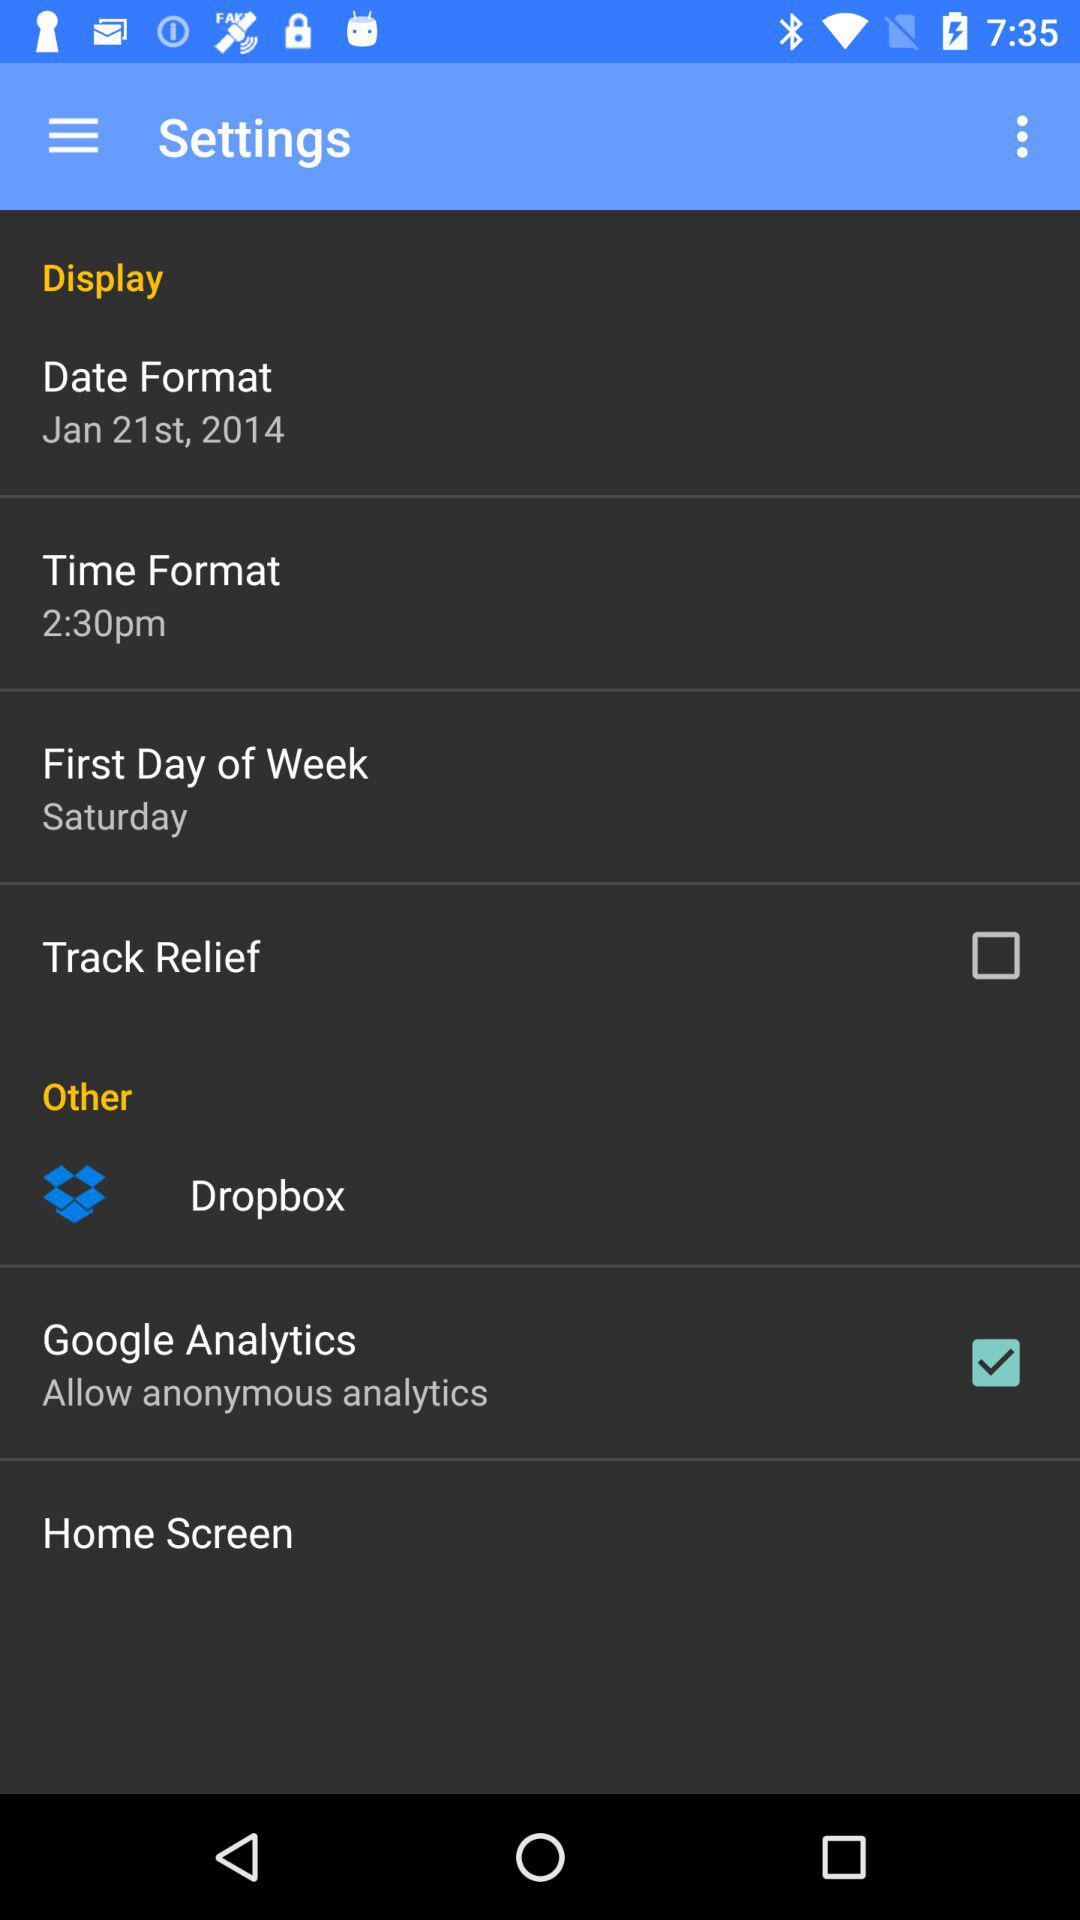What's the time format? The time format is 2:30 pm. 